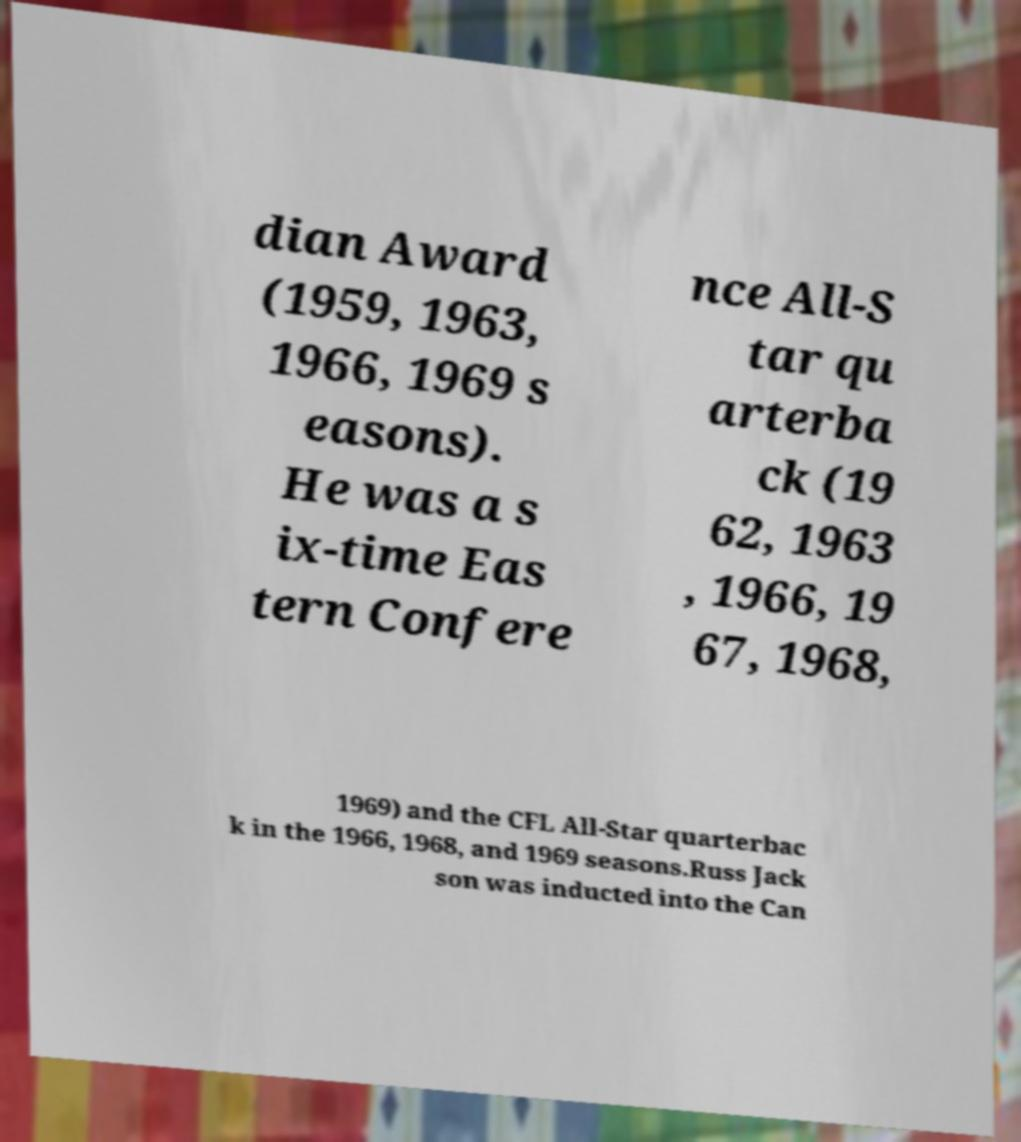For documentation purposes, I need the text within this image transcribed. Could you provide that? dian Award (1959, 1963, 1966, 1969 s easons). He was a s ix-time Eas tern Confere nce All-S tar qu arterba ck (19 62, 1963 , 1966, 19 67, 1968, 1969) and the CFL All-Star quarterbac k in the 1966, 1968, and 1969 seasons.Russ Jack son was inducted into the Can 